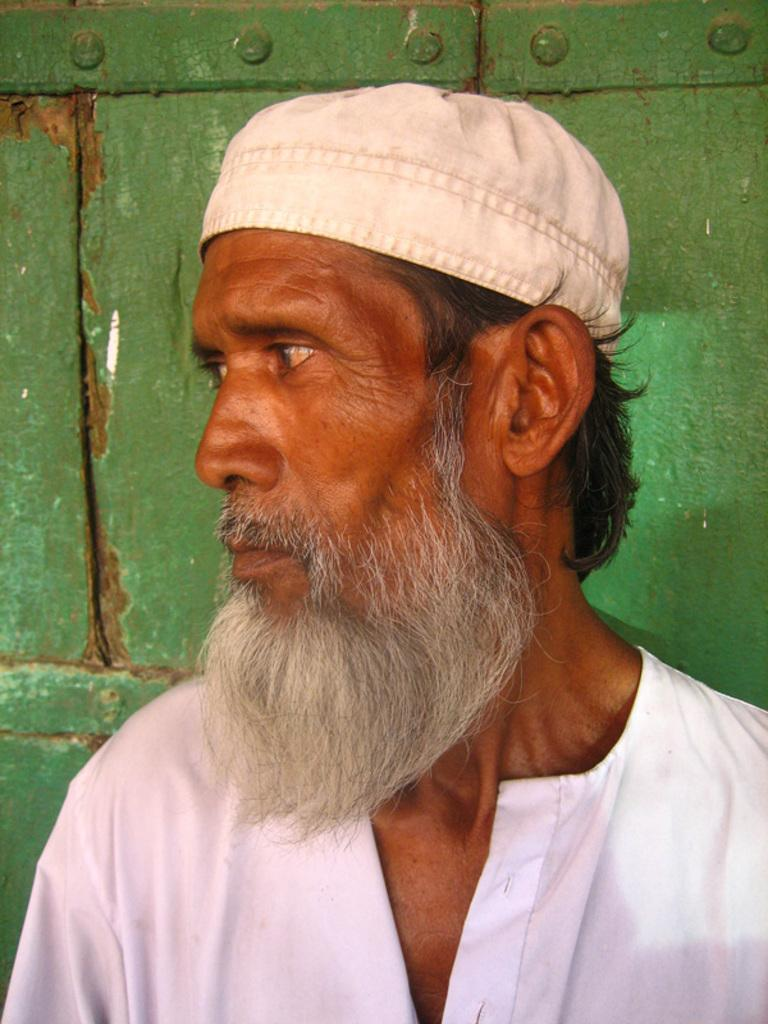Who is present in the image? There is a man in the image. What direction is the man looking in? The man is looking to the left side. What is the man wearing on his head? The man is wearing a cap. What color is the background of the image? The background of the image is green. How many hands does the man have in the image? The number of hands the man has cannot be determined from the image, as only one side of his body is visible. 